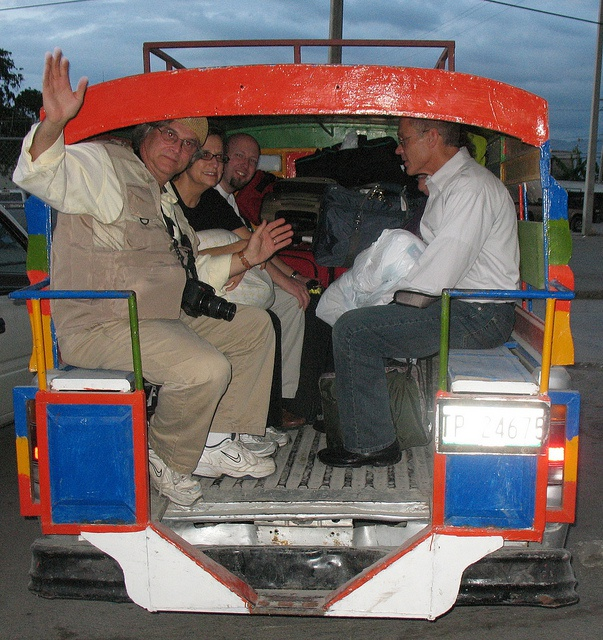Describe the objects in this image and their specific colors. I can see bus in lightgray, black, gray, and darkgray tones, people in lightgray, gray, and darkgray tones, people in lightgray, black, darkgray, gray, and purple tones, people in lightgray, black, brown, and gray tones, and car in lightgray, gray, black, and darkblue tones in this image. 